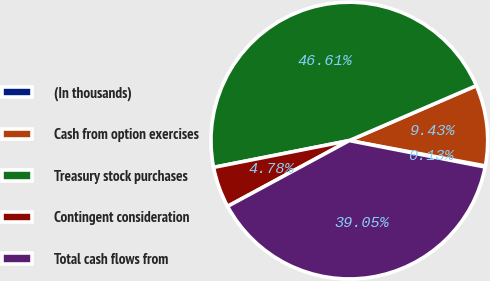<chart> <loc_0><loc_0><loc_500><loc_500><pie_chart><fcel>(In thousands)<fcel>Cash from option exercises<fcel>Treasury stock purchases<fcel>Contingent consideration<fcel>Total cash flows from<nl><fcel>0.13%<fcel>9.43%<fcel>46.61%<fcel>4.78%<fcel>39.05%<nl></chart> 